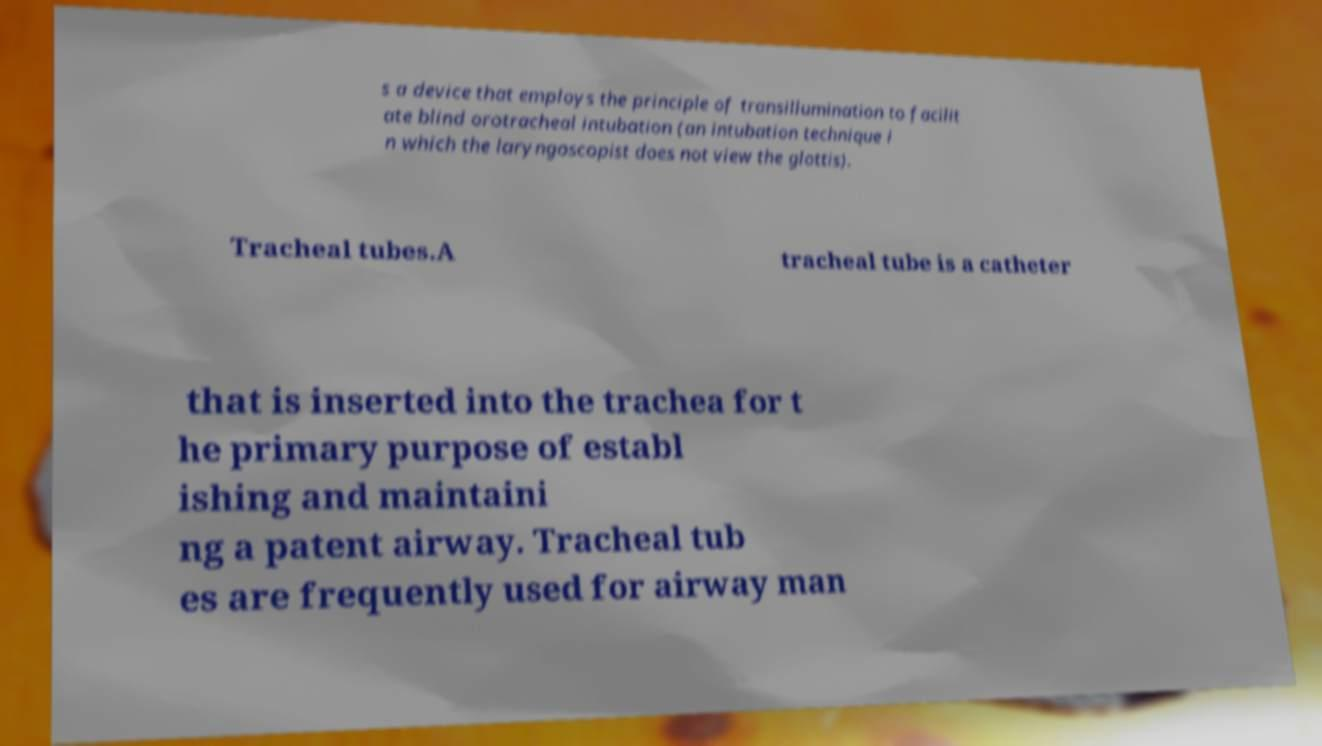Can you read and provide the text displayed in the image?This photo seems to have some interesting text. Can you extract and type it out for me? s a device that employs the principle of transillumination to facilit ate blind orotracheal intubation (an intubation technique i n which the laryngoscopist does not view the glottis). Tracheal tubes.A tracheal tube is a catheter that is inserted into the trachea for t he primary purpose of establ ishing and maintaini ng a patent airway. Tracheal tub es are frequently used for airway man 